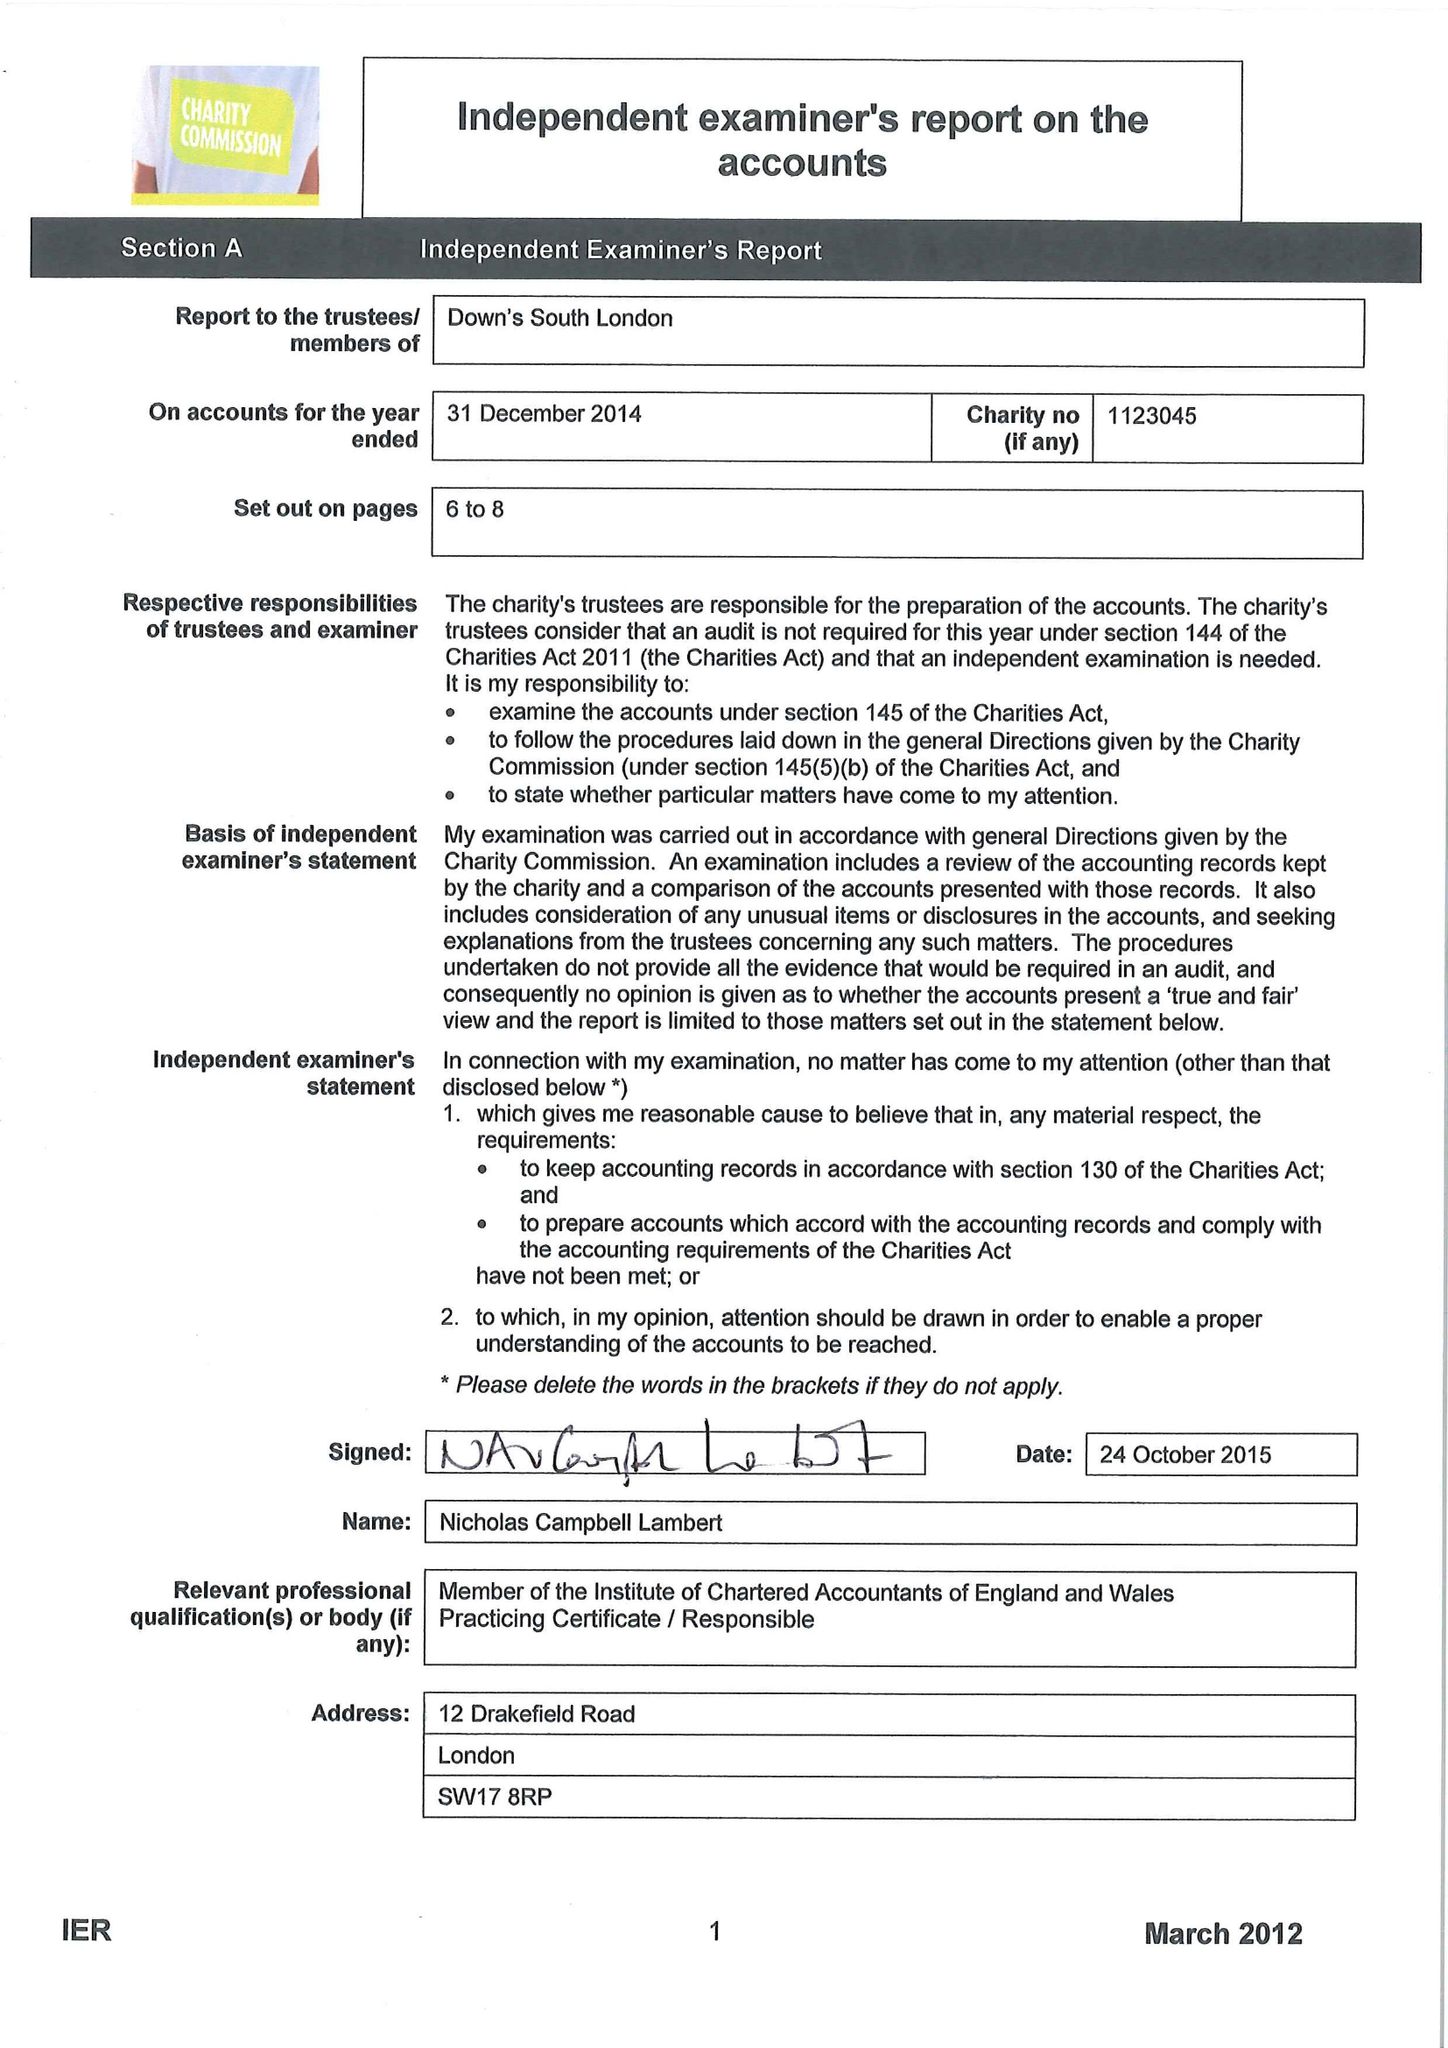What is the value for the address__street_line?
Answer the question using a single word or phrase. 59 LYNDHURST GROVE 